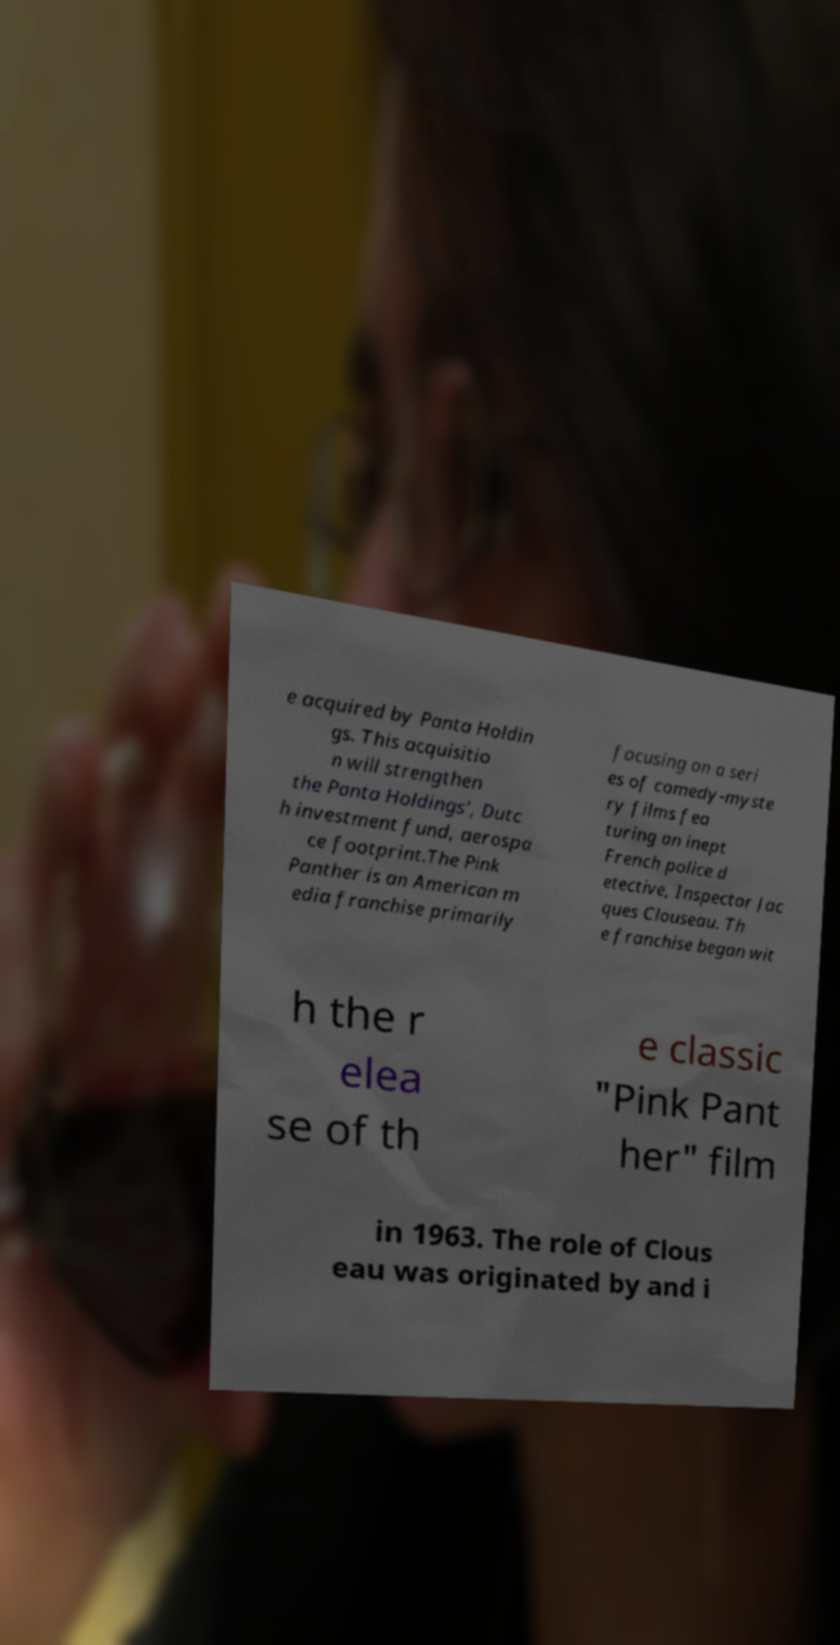Could you extract and type out the text from this image? e acquired by Panta Holdin gs. This acquisitio n will strengthen the Panta Holdings’, Dutc h investment fund, aerospa ce footprint.The Pink Panther is an American m edia franchise primarily focusing on a seri es of comedy-myste ry films fea turing an inept French police d etective, Inspector Jac ques Clouseau. Th e franchise began wit h the r elea se of th e classic "Pink Pant her" film in 1963. The role of Clous eau was originated by and i 